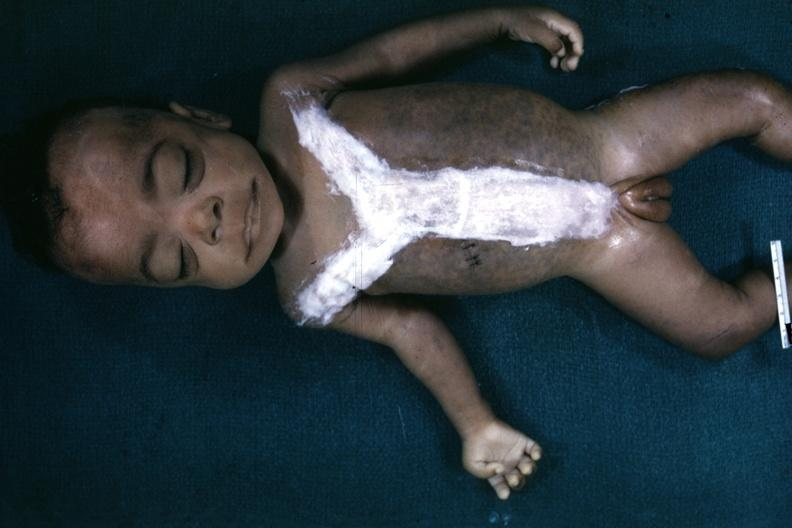what does this image show?
Answer the question using a single word or phrase. Whole body after autopsy with covered incision very good representation of mongoloid facies and one hand is opened to show simian crease quite good example 